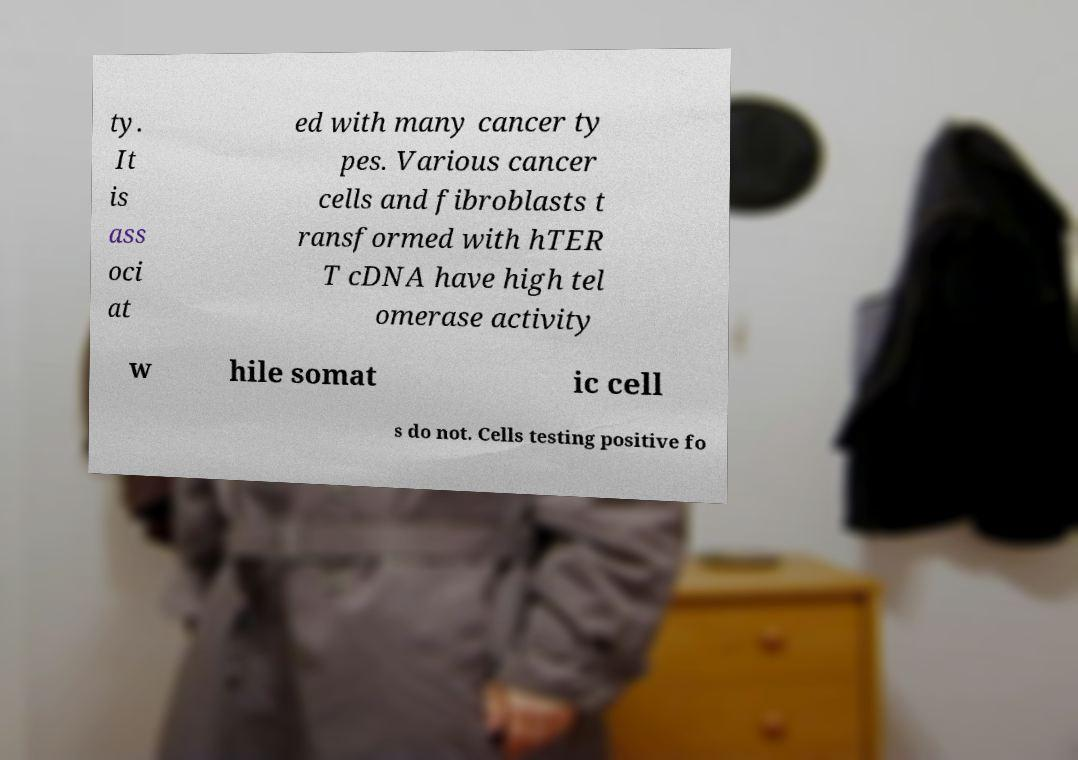Could you extract and type out the text from this image? ty. It is ass oci at ed with many cancer ty pes. Various cancer cells and fibroblasts t ransformed with hTER T cDNA have high tel omerase activity w hile somat ic cell s do not. Cells testing positive fo 